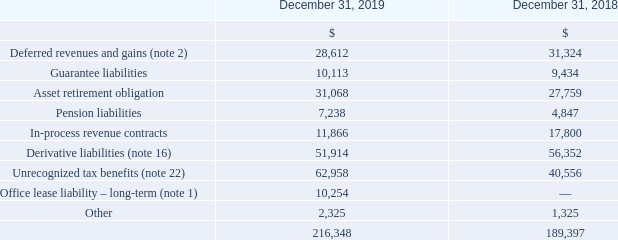Other Long-Term Liabilities
In-Process Revenue Contracts
As part of the Company’s previous acquisition of FPSO units from Petrojarl ASA (subsequently renamed Teekay Petrojarl AS, or Teekay Petrojarl), the Company assumed a certain FPSO contract with terms that were less favorable than the then prevailing market terms. At the time of the acquisition, the Company recognized a liability based on the estimated fair value of this contract and service obligation.
The Company is amortizing the remaining liability over the estimated remaining term of its associated contract on a weighted basis, based on the projected revenue to be earned under the contract.
Amortization of in-process revenue contracts for the year ended December 31, 2019 was $5.9 million (2018 – $14.5 million, 2017 – $27.2 million), which is included in revenues on the consolidated statements of loss. Amortization of in-process revenue contracts following 2019 is expected to be $5.9 million (2020), $5.9 million (2021) and $5.9 million (2022).
What was Amortization of in-process revenue contracts for the year ended December 31, 2019? Amortization of in-process revenue contracts for the year ended december 31, 2019 was $5.9 million. What was amortization of in-process revenue contracts for the year 2020, 2021 and 2022? Amortization of in-process revenue contracts following 2019 is expected to be $5.9 million (2020), $5.9 million (2021) and $5.9 million (2022). What was Amortization of in-process revenue contracts for the year 2018 and 2017? (2018 – $14.5 million, 2017 – $27.2 million). What is the increase/ (decrease) in Deferred revenues and gains from December 31, 2019 to December 31, 2018?
Answer scale should be: million. 28,612-31,324
Answer: -2712. What is the increase/ (decrease) in Guarantee liabilities from December 31, 2019 to December 31, 2018?
Answer scale should be: million. 10,113-9,434
Answer: 679. What is the increase/ (decrease) in Asset retirement obligation from December 31, 2019 to December 31, 2018?
Answer scale should be: million. 31,068-27,759
Answer: 3309. 